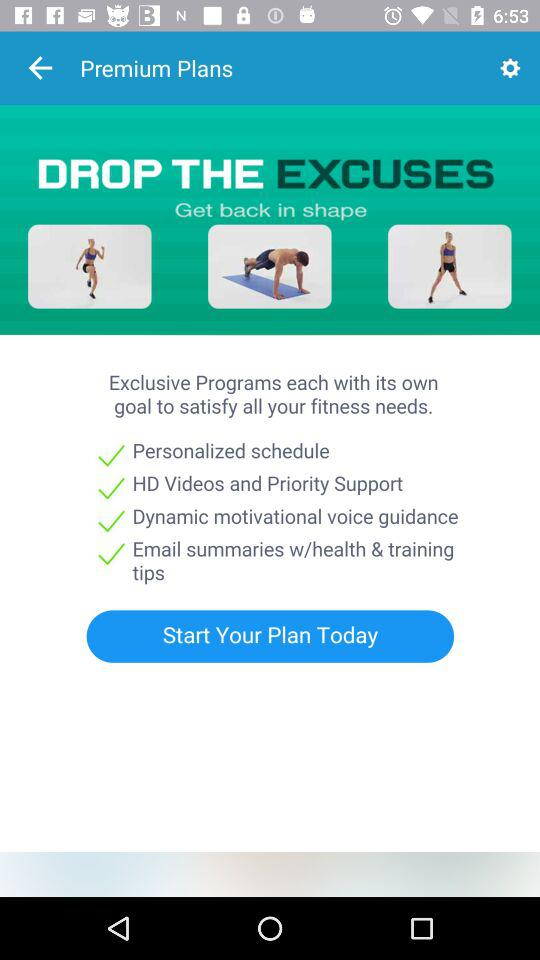What is the status of the personalized schedule?
When the provided information is insufficient, respond with <no answer>. <no answer> 